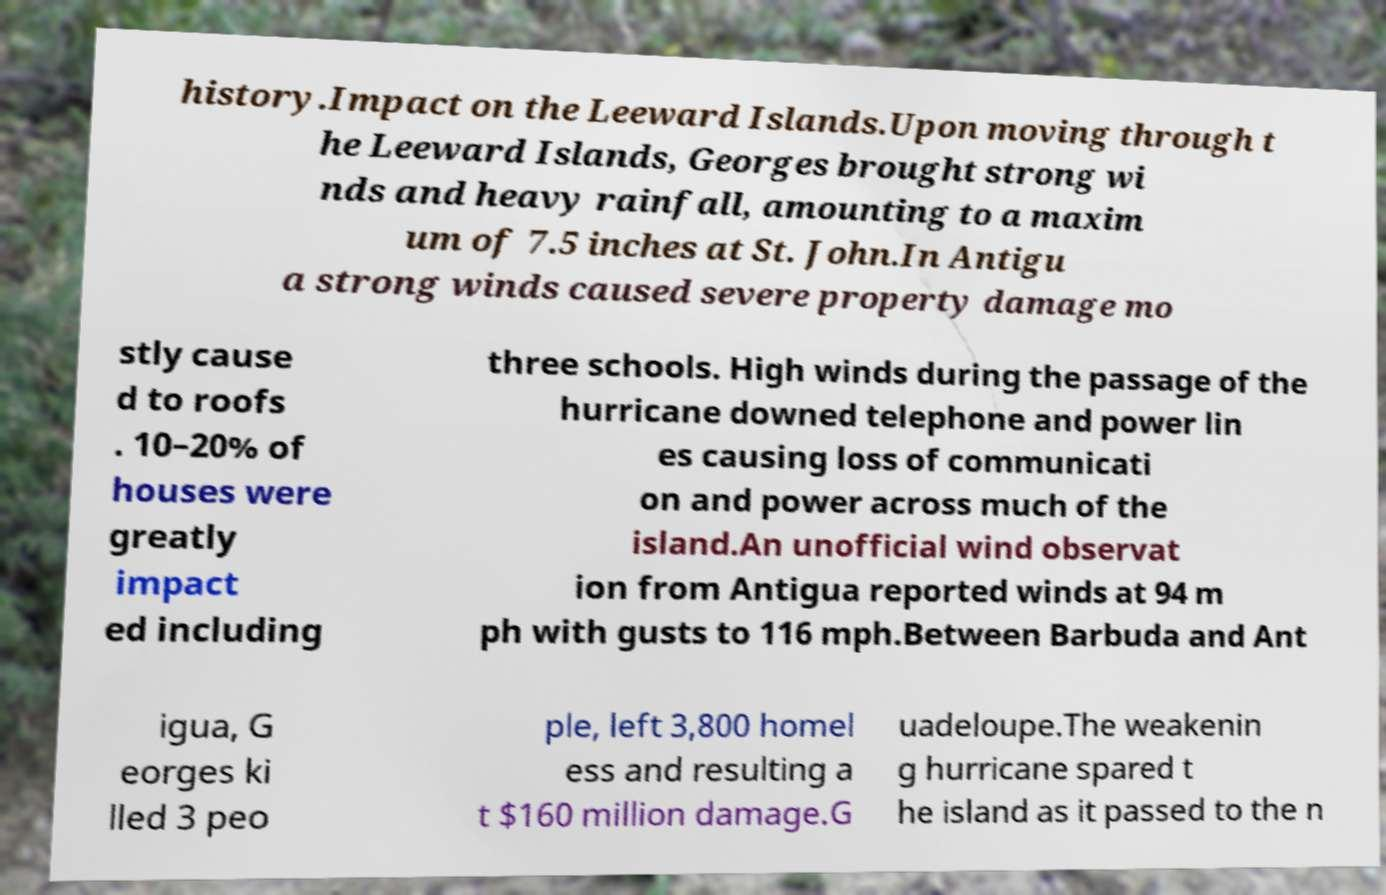For documentation purposes, I need the text within this image transcribed. Could you provide that? history.Impact on the Leeward Islands.Upon moving through t he Leeward Islands, Georges brought strong wi nds and heavy rainfall, amounting to a maxim um of 7.5 inches at St. John.In Antigu a strong winds caused severe property damage mo stly cause d to roofs . 10–20% of houses were greatly impact ed including three schools. High winds during the passage of the hurricane downed telephone and power lin es causing loss of communicati on and power across much of the island.An unofficial wind observat ion from Antigua reported winds at 94 m ph with gusts to 116 mph.Between Barbuda and Ant igua, G eorges ki lled 3 peo ple, left 3,800 homel ess and resulting a t $160 million damage.G uadeloupe.The weakenin g hurricane spared t he island as it passed to the n 